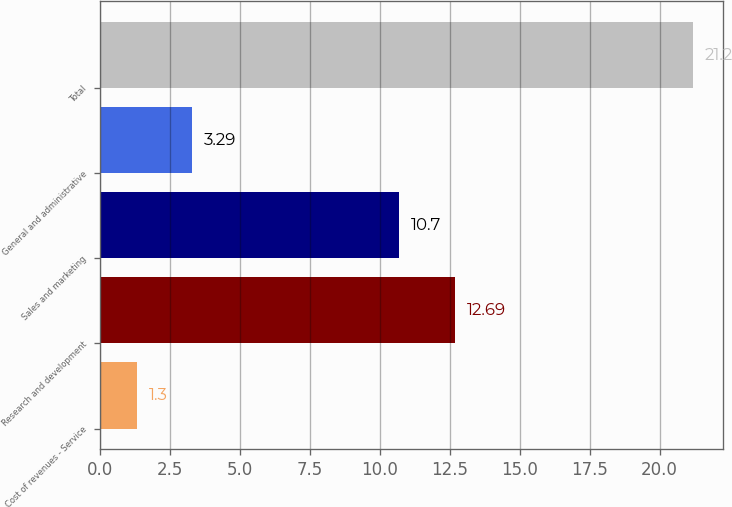<chart> <loc_0><loc_0><loc_500><loc_500><bar_chart><fcel>Cost of revenues - Service<fcel>Research and development<fcel>Sales and marketing<fcel>General and administrative<fcel>Total<nl><fcel>1.3<fcel>12.69<fcel>10.7<fcel>3.29<fcel>21.2<nl></chart> 